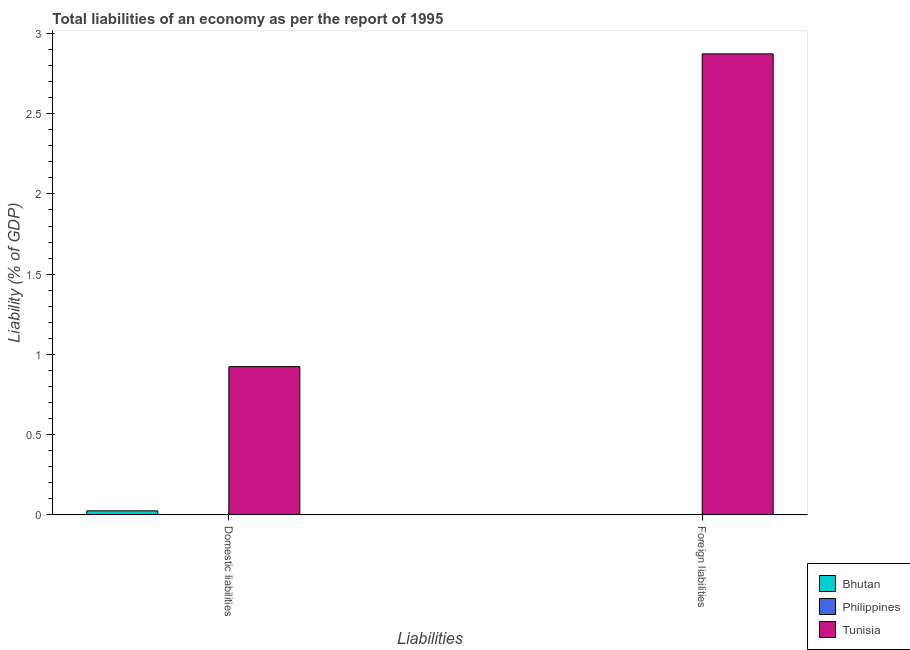How many bars are there on the 1st tick from the right?
Make the answer very short. 1. What is the label of the 2nd group of bars from the left?
Provide a succinct answer. Foreign liabilities. What is the incurrence of domestic liabilities in Bhutan?
Give a very brief answer. 0.03. Across all countries, what is the maximum incurrence of domestic liabilities?
Your response must be concise. 0.92. In which country was the incurrence of foreign liabilities maximum?
Provide a succinct answer. Tunisia. What is the total incurrence of domestic liabilities in the graph?
Ensure brevity in your answer.  0.95. What is the difference between the incurrence of domestic liabilities in Tunisia and that in Bhutan?
Provide a short and direct response. 0.9. What is the difference between the incurrence of domestic liabilities in Bhutan and the incurrence of foreign liabilities in Tunisia?
Give a very brief answer. -2.85. What is the average incurrence of domestic liabilities per country?
Provide a short and direct response. 0.32. What is the difference between the incurrence of domestic liabilities and incurrence of foreign liabilities in Tunisia?
Offer a terse response. -1.95. In how many countries, is the incurrence of domestic liabilities greater than 2.2 %?
Give a very brief answer. 0. How many bars are there?
Your response must be concise. 3. Are all the bars in the graph horizontal?
Offer a terse response. No. Are the values on the major ticks of Y-axis written in scientific E-notation?
Offer a very short reply. No. Where does the legend appear in the graph?
Give a very brief answer. Bottom right. How are the legend labels stacked?
Your answer should be compact. Vertical. What is the title of the graph?
Your answer should be compact. Total liabilities of an economy as per the report of 1995. What is the label or title of the X-axis?
Make the answer very short. Liabilities. What is the label or title of the Y-axis?
Provide a short and direct response. Liability (% of GDP). What is the Liability (% of GDP) in Bhutan in Domestic liabilities?
Your response must be concise. 0.03. What is the Liability (% of GDP) of Tunisia in Domestic liabilities?
Your response must be concise. 0.92. What is the Liability (% of GDP) of Philippines in Foreign liabilities?
Give a very brief answer. 0. What is the Liability (% of GDP) in Tunisia in Foreign liabilities?
Your answer should be very brief. 2.87. Across all Liabilities, what is the maximum Liability (% of GDP) of Bhutan?
Your response must be concise. 0.03. Across all Liabilities, what is the maximum Liability (% of GDP) of Tunisia?
Offer a terse response. 2.87. Across all Liabilities, what is the minimum Liability (% of GDP) of Bhutan?
Your answer should be very brief. 0. Across all Liabilities, what is the minimum Liability (% of GDP) of Tunisia?
Your answer should be very brief. 0.92. What is the total Liability (% of GDP) in Bhutan in the graph?
Provide a short and direct response. 0.03. What is the total Liability (% of GDP) of Philippines in the graph?
Give a very brief answer. 0. What is the total Liability (% of GDP) of Tunisia in the graph?
Give a very brief answer. 3.8. What is the difference between the Liability (% of GDP) in Tunisia in Domestic liabilities and that in Foreign liabilities?
Your answer should be compact. -1.95. What is the difference between the Liability (% of GDP) of Bhutan in Domestic liabilities and the Liability (% of GDP) of Tunisia in Foreign liabilities?
Provide a succinct answer. -2.85. What is the average Liability (% of GDP) in Bhutan per Liabilities?
Give a very brief answer. 0.01. What is the average Liability (% of GDP) in Tunisia per Liabilities?
Your answer should be very brief. 1.9. What is the difference between the Liability (% of GDP) in Bhutan and Liability (% of GDP) in Tunisia in Domestic liabilities?
Offer a terse response. -0.9. What is the ratio of the Liability (% of GDP) of Tunisia in Domestic liabilities to that in Foreign liabilities?
Provide a short and direct response. 0.32. What is the difference between the highest and the second highest Liability (% of GDP) in Tunisia?
Give a very brief answer. 1.95. What is the difference between the highest and the lowest Liability (% of GDP) in Bhutan?
Ensure brevity in your answer.  0.03. What is the difference between the highest and the lowest Liability (% of GDP) of Tunisia?
Your answer should be very brief. 1.95. 